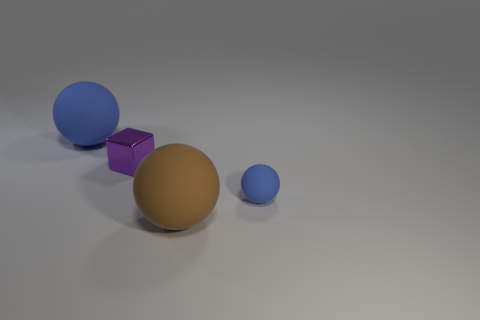Add 2 blue rubber spheres. How many objects exist? 6 Subtract all cubes. How many objects are left? 3 Add 2 small objects. How many small objects exist? 4 Subtract 0 green cylinders. How many objects are left? 4 Subtract all small purple metal blocks. Subtract all tiny matte things. How many objects are left? 2 Add 4 large matte objects. How many large matte objects are left? 6 